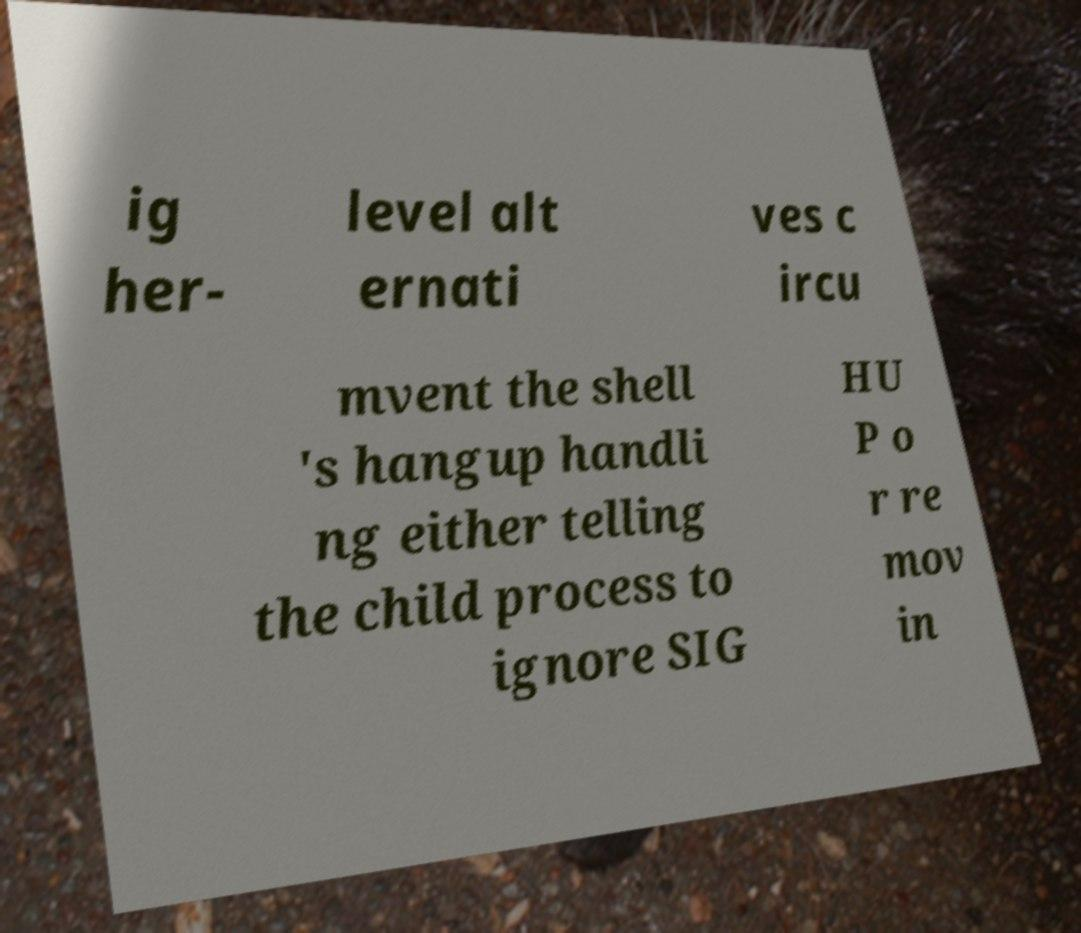There's text embedded in this image that I need extracted. Can you transcribe it verbatim? ig her- level alt ernati ves c ircu mvent the shell 's hangup handli ng either telling the child process to ignore SIG HU P o r re mov in 